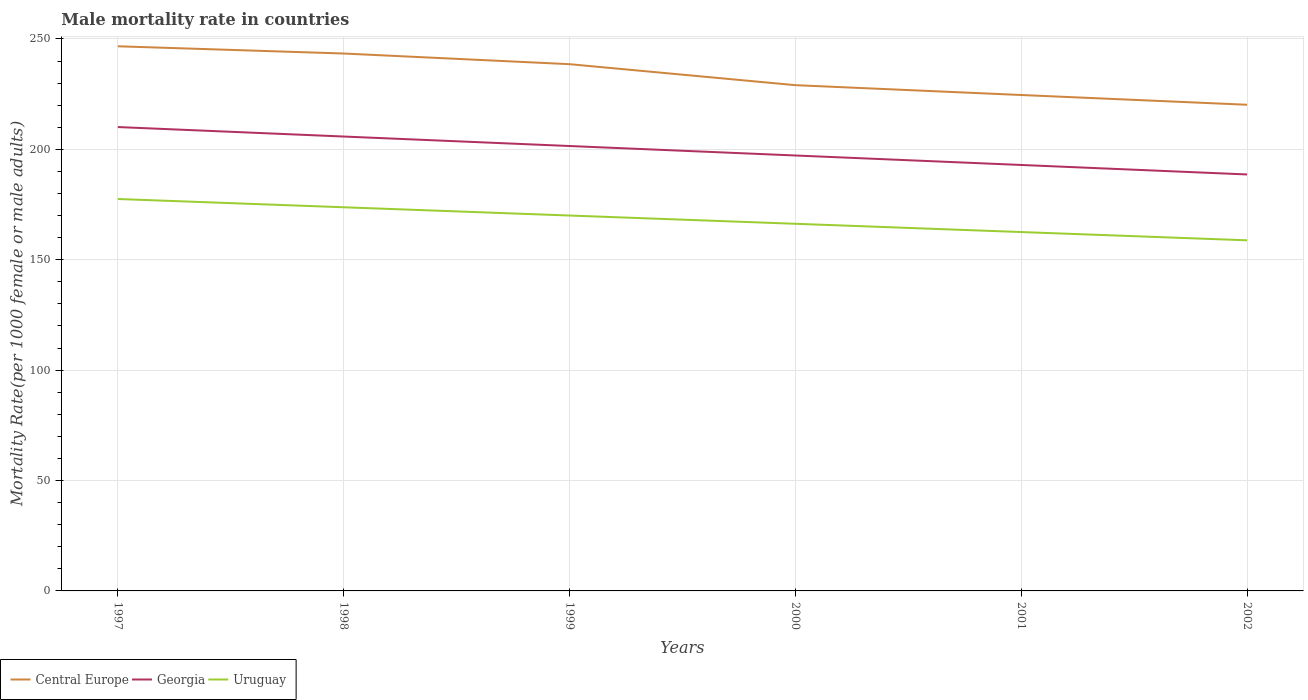Does the line corresponding to Uruguay intersect with the line corresponding to Georgia?
Make the answer very short. No. Is the number of lines equal to the number of legend labels?
Keep it short and to the point. Yes. Across all years, what is the maximum male mortality rate in Uruguay?
Make the answer very short. 158.8. In which year was the male mortality rate in Uruguay maximum?
Your answer should be compact. 2002. What is the total male mortality rate in Georgia in the graph?
Offer a very short reply. 17.18. What is the difference between the highest and the second highest male mortality rate in Central Europe?
Offer a terse response. 26.48. What is the difference between the highest and the lowest male mortality rate in Central Europe?
Your answer should be compact. 3. Is the male mortality rate in Uruguay strictly greater than the male mortality rate in Central Europe over the years?
Offer a very short reply. Yes. How many years are there in the graph?
Provide a succinct answer. 6. What is the difference between two consecutive major ticks on the Y-axis?
Your response must be concise. 50. What is the title of the graph?
Provide a succinct answer. Male mortality rate in countries. Does "Peru" appear as one of the legend labels in the graph?
Provide a succinct answer. No. What is the label or title of the Y-axis?
Offer a very short reply. Mortality Rate(per 1000 female or male adults). What is the Mortality Rate(per 1000 female or male adults) in Central Europe in 1997?
Give a very brief answer. 246.68. What is the Mortality Rate(per 1000 female or male adults) in Georgia in 1997?
Ensure brevity in your answer.  210.09. What is the Mortality Rate(per 1000 female or male adults) in Uruguay in 1997?
Offer a very short reply. 177.51. What is the Mortality Rate(per 1000 female or male adults) in Central Europe in 1998?
Your answer should be very brief. 243.4. What is the Mortality Rate(per 1000 female or male adults) in Georgia in 1998?
Give a very brief answer. 205.8. What is the Mortality Rate(per 1000 female or male adults) of Uruguay in 1998?
Ensure brevity in your answer.  173.76. What is the Mortality Rate(per 1000 female or male adults) of Central Europe in 1999?
Give a very brief answer. 238.57. What is the Mortality Rate(per 1000 female or male adults) of Georgia in 1999?
Provide a short and direct response. 201.51. What is the Mortality Rate(per 1000 female or male adults) in Uruguay in 1999?
Provide a succinct answer. 170.02. What is the Mortality Rate(per 1000 female or male adults) in Central Europe in 2000?
Your response must be concise. 229.07. What is the Mortality Rate(per 1000 female or male adults) of Georgia in 2000?
Keep it short and to the point. 197.21. What is the Mortality Rate(per 1000 female or male adults) in Uruguay in 2000?
Give a very brief answer. 166.28. What is the Mortality Rate(per 1000 female or male adults) in Central Europe in 2001?
Your answer should be very brief. 224.61. What is the Mortality Rate(per 1000 female or male adults) in Georgia in 2001?
Your answer should be compact. 192.92. What is the Mortality Rate(per 1000 female or male adults) in Uruguay in 2001?
Your answer should be compact. 162.54. What is the Mortality Rate(per 1000 female or male adults) of Central Europe in 2002?
Your response must be concise. 220.2. What is the Mortality Rate(per 1000 female or male adults) in Georgia in 2002?
Ensure brevity in your answer.  188.62. What is the Mortality Rate(per 1000 female or male adults) in Uruguay in 2002?
Ensure brevity in your answer.  158.8. Across all years, what is the maximum Mortality Rate(per 1000 female or male adults) in Central Europe?
Provide a short and direct response. 246.68. Across all years, what is the maximum Mortality Rate(per 1000 female or male adults) of Georgia?
Give a very brief answer. 210.09. Across all years, what is the maximum Mortality Rate(per 1000 female or male adults) in Uruguay?
Offer a terse response. 177.51. Across all years, what is the minimum Mortality Rate(per 1000 female or male adults) in Central Europe?
Provide a succinct answer. 220.2. Across all years, what is the minimum Mortality Rate(per 1000 female or male adults) of Georgia?
Offer a very short reply. 188.62. Across all years, what is the minimum Mortality Rate(per 1000 female or male adults) of Uruguay?
Offer a very short reply. 158.8. What is the total Mortality Rate(per 1000 female or male adults) in Central Europe in the graph?
Make the answer very short. 1402.52. What is the total Mortality Rate(per 1000 female or male adults) of Georgia in the graph?
Ensure brevity in your answer.  1196.16. What is the total Mortality Rate(per 1000 female or male adults) of Uruguay in the graph?
Make the answer very short. 1008.91. What is the difference between the Mortality Rate(per 1000 female or male adults) in Central Europe in 1997 and that in 1998?
Your answer should be compact. 3.28. What is the difference between the Mortality Rate(per 1000 female or male adults) of Georgia in 1997 and that in 1998?
Offer a very short reply. 4.29. What is the difference between the Mortality Rate(per 1000 female or male adults) of Uruguay in 1997 and that in 1998?
Your answer should be compact. 3.74. What is the difference between the Mortality Rate(per 1000 female or male adults) of Central Europe in 1997 and that in 1999?
Ensure brevity in your answer.  8.11. What is the difference between the Mortality Rate(per 1000 female or male adults) of Georgia in 1997 and that in 1999?
Offer a terse response. 8.59. What is the difference between the Mortality Rate(per 1000 female or male adults) in Uruguay in 1997 and that in 1999?
Offer a terse response. 7.48. What is the difference between the Mortality Rate(per 1000 female or male adults) in Central Europe in 1997 and that in 2000?
Make the answer very short. 17.61. What is the difference between the Mortality Rate(per 1000 female or male adults) of Georgia in 1997 and that in 2000?
Offer a terse response. 12.88. What is the difference between the Mortality Rate(per 1000 female or male adults) in Uruguay in 1997 and that in 2000?
Provide a short and direct response. 11.23. What is the difference between the Mortality Rate(per 1000 female or male adults) in Central Europe in 1997 and that in 2001?
Your answer should be compact. 22.07. What is the difference between the Mortality Rate(per 1000 female or male adults) in Georgia in 1997 and that in 2001?
Keep it short and to the point. 17.18. What is the difference between the Mortality Rate(per 1000 female or male adults) in Uruguay in 1997 and that in 2001?
Your answer should be very brief. 14.97. What is the difference between the Mortality Rate(per 1000 female or male adults) in Central Europe in 1997 and that in 2002?
Your answer should be very brief. 26.48. What is the difference between the Mortality Rate(per 1000 female or male adults) in Georgia in 1997 and that in 2002?
Your response must be concise. 21.47. What is the difference between the Mortality Rate(per 1000 female or male adults) of Uruguay in 1997 and that in 2002?
Your answer should be compact. 18.71. What is the difference between the Mortality Rate(per 1000 female or male adults) of Central Europe in 1998 and that in 1999?
Your answer should be compact. 4.83. What is the difference between the Mortality Rate(per 1000 female or male adults) in Georgia in 1998 and that in 1999?
Offer a very short reply. 4.29. What is the difference between the Mortality Rate(per 1000 female or male adults) of Uruguay in 1998 and that in 1999?
Your answer should be compact. 3.74. What is the difference between the Mortality Rate(per 1000 female or male adults) of Central Europe in 1998 and that in 2000?
Ensure brevity in your answer.  14.33. What is the difference between the Mortality Rate(per 1000 female or male adults) of Georgia in 1998 and that in 2000?
Ensure brevity in your answer.  8.59. What is the difference between the Mortality Rate(per 1000 female or male adults) in Uruguay in 1998 and that in 2000?
Ensure brevity in your answer.  7.48. What is the difference between the Mortality Rate(per 1000 female or male adults) in Central Europe in 1998 and that in 2001?
Make the answer very short. 18.79. What is the difference between the Mortality Rate(per 1000 female or male adults) of Georgia in 1998 and that in 2001?
Provide a succinct answer. 12.88. What is the difference between the Mortality Rate(per 1000 female or male adults) of Uruguay in 1998 and that in 2001?
Make the answer very short. 11.23. What is the difference between the Mortality Rate(per 1000 female or male adults) in Central Europe in 1998 and that in 2002?
Keep it short and to the point. 23.2. What is the difference between the Mortality Rate(per 1000 female or male adults) in Georgia in 1998 and that in 2002?
Offer a terse response. 17.18. What is the difference between the Mortality Rate(per 1000 female or male adults) in Uruguay in 1998 and that in 2002?
Offer a terse response. 14.97. What is the difference between the Mortality Rate(per 1000 female or male adults) of Central Europe in 1999 and that in 2000?
Give a very brief answer. 9.5. What is the difference between the Mortality Rate(per 1000 female or male adults) in Georgia in 1999 and that in 2000?
Keep it short and to the point. 4.29. What is the difference between the Mortality Rate(per 1000 female or male adults) of Uruguay in 1999 and that in 2000?
Ensure brevity in your answer.  3.74. What is the difference between the Mortality Rate(per 1000 female or male adults) of Central Europe in 1999 and that in 2001?
Ensure brevity in your answer.  13.96. What is the difference between the Mortality Rate(per 1000 female or male adults) of Georgia in 1999 and that in 2001?
Ensure brevity in your answer.  8.59. What is the difference between the Mortality Rate(per 1000 female or male adults) in Uruguay in 1999 and that in 2001?
Give a very brief answer. 7.48. What is the difference between the Mortality Rate(per 1000 female or male adults) of Central Europe in 1999 and that in 2002?
Your answer should be very brief. 18.37. What is the difference between the Mortality Rate(per 1000 female or male adults) in Georgia in 1999 and that in 2002?
Your answer should be very brief. 12.88. What is the difference between the Mortality Rate(per 1000 female or male adults) of Uruguay in 1999 and that in 2002?
Give a very brief answer. 11.23. What is the difference between the Mortality Rate(per 1000 female or male adults) in Central Europe in 2000 and that in 2001?
Your answer should be compact. 4.46. What is the difference between the Mortality Rate(per 1000 female or male adults) in Georgia in 2000 and that in 2001?
Your answer should be very brief. 4.29. What is the difference between the Mortality Rate(per 1000 female or male adults) in Uruguay in 2000 and that in 2001?
Keep it short and to the point. 3.74. What is the difference between the Mortality Rate(per 1000 female or male adults) of Central Europe in 2000 and that in 2002?
Offer a terse response. 8.87. What is the difference between the Mortality Rate(per 1000 female or male adults) of Georgia in 2000 and that in 2002?
Provide a short and direct response. 8.59. What is the difference between the Mortality Rate(per 1000 female or male adults) in Uruguay in 2000 and that in 2002?
Offer a terse response. 7.48. What is the difference between the Mortality Rate(per 1000 female or male adults) in Central Europe in 2001 and that in 2002?
Offer a terse response. 4.41. What is the difference between the Mortality Rate(per 1000 female or male adults) of Georgia in 2001 and that in 2002?
Make the answer very short. 4.29. What is the difference between the Mortality Rate(per 1000 female or male adults) in Uruguay in 2001 and that in 2002?
Keep it short and to the point. 3.74. What is the difference between the Mortality Rate(per 1000 female or male adults) of Central Europe in 1997 and the Mortality Rate(per 1000 female or male adults) of Georgia in 1998?
Your response must be concise. 40.88. What is the difference between the Mortality Rate(per 1000 female or male adults) of Central Europe in 1997 and the Mortality Rate(per 1000 female or male adults) of Uruguay in 1998?
Your response must be concise. 72.91. What is the difference between the Mortality Rate(per 1000 female or male adults) of Georgia in 1997 and the Mortality Rate(per 1000 female or male adults) of Uruguay in 1998?
Offer a very short reply. 36.33. What is the difference between the Mortality Rate(per 1000 female or male adults) of Central Europe in 1997 and the Mortality Rate(per 1000 female or male adults) of Georgia in 1999?
Give a very brief answer. 45.17. What is the difference between the Mortality Rate(per 1000 female or male adults) in Central Europe in 1997 and the Mortality Rate(per 1000 female or male adults) in Uruguay in 1999?
Ensure brevity in your answer.  76.66. What is the difference between the Mortality Rate(per 1000 female or male adults) of Georgia in 1997 and the Mortality Rate(per 1000 female or male adults) of Uruguay in 1999?
Provide a succinct answer. 40.07. What is the difference between the Mortality Rate(per 1000 female or male adults) in Central Europe in 1997 and the Mortality Rate(per 1000 female or male adults) in Georgia in 2000?
Make the answer very short. 49.47. What is the difference between the Mortality Rate(per 1000 female or male adults) in Central Europe in 1997 and the Mortality Rate(per 1000 female or male adults) in Uruguay in 2000?
Your response must be concise. 80.4. What is the difference between the Mortality Rate(per 1000 female or male adults) of Georgia in 1997 and the Mortality Rate(per 1000 female or male adults) of Uruguay in 2000?
Your response must be concise. 43.81. What is the difference between the Mortality Rate(per 1000 female or male adults) in Central Europe in 1997 and the Mortality Rate(per 1000 female or male adults) in Georgia in 2001?
Give a very brief answer. 53.76. What is the difference between the Mortality Rate(per 1000 female or male adults) in Central Europe in 1997 and the Mortality Rate(per 1000 female or male adults) in Uruguay in 2001?
Ensure brevity in your answer.  84.14. What is the difference between the Mortality Rate(per 1000 female or male adults) in Georgia in 1997 and the Mortality Rate(per 1000 female or male adults) in Uruguay in 2001?
Your response must be concise. 47.55. What is the difference between the Mortality Rate(per 1000 female or male adults) of Central Europe in 1997 and the Mortality Rate(per 1000 female or male adults) of Georgia in 2002?
Your answer should be compact. 58.05. What is the difference between the Mortality Rate(per 1000 female or male adults) in Central Europe in 1997 and the Mortality Rate(per 1000 female or male adults) in Uruguay in 2002?
Provide a short and direct response. 87.88. What is the difference between the Mortality Rate(per 1000 female or male adults) in Georgia in 1997 and the Mortality Rate(per 1000 female or male adults) in Uruguay in 2002?
Your answer should be compact. 51.3. What is the difference between the Mortality Rate(per 1000 female or male adults) in Central Europe in 1998 and the Mortality Rate(per 1000 female or male adults) in Georgia in 1999?
Provide a succinct answer. 41.89. What is the difference between the Mortality Rate(per 1000 female or male adults) of Central Europe in 1998 and the Mortality Rate(per 1000 female or male adults) of Uruguay in 1999?
Offer a very short reply. 73.38. What is the difference between the Mortality Rate(per 1000 female or male adults) in Georgia in 1998 and the Mortality Rate(per 1000 female or male adults) in Uruguay in 1999?
Offer a terse response. 35.78. What is the difference between the Mortality Rate(per 1000 female or male adults) in Central Europe in 1998 and the Mortality Rate(per 1000 female or male adults) in Georgia in 2000?
Make the answer very short. 46.19. What is the difference between the Mortality Rate(per 1000 female or male adults) in Central Europe in 1998 and the Mortality Rate(per 1000 female or male adults) in Uruguay in 2000?
Your answer should be very brief. 77.12. What is the difference between the Mortality Rate(per 1000 female or male adults) in Georgia in 1998 and the Mortality Rate(per 1000 female or male adults) in Uruguay in 2000?
Provide a succinct answer. 39.52. What is the difference between the Mortality Rate(per 1000 female or male adults) in Central Europe in 1998 and the Mortality Rate(per 1000 female or male adults) in Georgia in 2001?
Give a very brief answer. 50.48. What is the difference between the Mortality Rate(per 1000 female or male adults) of Central Europe in 1998 and the Mortality Rate(per 1000 female or male adults) of Uruguay in 2001?
Your answer should be very brief. 80.86. What is the difference between the Mortality Rate(per 1000 female or male adults) of Georgia in 1998 and the Mortality Rate(per 1000 female or male adults) of Uruguay in 2001?
Your answer should be very brief. 43.26. What is the difference between the Mortality Rate(per 1000 female or male adults) of Central Europe in 1998 and the Mortality Rate(per 1000 female or male adults) of Georgia in 2002?
Your answer should be compact. 54.77. What is the difference between the Mortality Rate(per 1000 female or male adults) of Central Europe in 1998 and the Mortality Rate(per 1000 female or male adults) of Uruguay in 2002?
Give a very brief answer. 84.6. What is the difference between the Mortality Rate(per 1000 female or male adults) of Georgia in 1998 and the Mortality Rate(per 1000 female or male adults) of Uruguay in 2002?
Offer a terse response. 47. What is the difference between the Mortality Rate(per 1000 female or male adults) in Central Europe in 1999 and the Mortality Rate(per 1000 female or male adults) in Georgia in 2000?
Keep it short and to the point. 41.36. What is the difference between the Mortality Rate(per 1000 female or male adults) of Central Europe in 1999 and the Mortality Rate(per 1000 female or male adults) of Uruguay in 2000?
Make the answer very short. 72.29. What is the difference between the Mortality Rate(per 1000 female or male adults) of Georgia in 1999 and the Mortality Rate(per 1000 female or male adults) of Uruguay in 2000?
Provide a short and direct response. 35.23. What is the difference between the Mortality Rate(per 1000 female or male adults) in Central Europe in 1999 and the Mortality Rate(per 1000 female or male adults) in Georgia in 2001?
Make the answer very short. 45.65. What is the difference between the Mortality Rate(per 1000 female or male adults) in Central Europe in 1999 and the Mortality Rate(per 1000 female or male adults) in Uruguay in 2001?
Give a very brief answer. 76.03. What is the difference between the Mortality Rate(per 1000 female or male adults) of Georgia in 1999 and the Mortality Rate(per 1000 female or male adults) of Uruguay in 2001?
Provide a short and direct response. 38.97. What is the difference between the Mortality Rate(per 1000 female or male adults) in Central Europe in 1999 and the Mortality Rate(per 1000 female or male adults) in Georgia in 2002?
Your answer should be very brief. 49.94. What is the difference between the Mortality Rate(per 1000 female or male adults) of Central Europe in 1999 and the Mortality Rate(per 1000 female or male adults) of Uruguay in 2002?
Offer a terse response. 79.77. What is the difference between the Mortality Rate(per 1000 female or male adults) in Georgia in 1999 and the Mortality Rate(per 1000 female or male adults) in Uruguay in 2002?
Make the answer very short. 42.71. What is the difference between the Mortality Rate(per 1000 female or male adults) of Central Europe in 2000 and the Mortality Rate(per 1000 female or male adults) of Georgia in 2001?
Your answer should be compact. 36.15. What is the difference between the Mortality Rate(per 1000 female or male adults) of Central Europe in 2000 and the Mortality Rate(per 1000 female or male adults) of Uruguay in 2001?
Ensure brevity in your answer.  66.53. What is the difference between the Mortality Rate(per 1000 female or male adults) in Georgia in 2000 and the Mortality Rate(per 1000 female or male adults) in Uruguay in 2001?
Provide a short and direct response. 34.67. What is the difference between the Mortality Rate(per 1000 female or male adults) in Central Europe in 2000 and the Mortality Rate(per 1000 female or male adults) in Georgia in 2002?
Give a very brief answer. 40.44. What is the difference between the Mortality Rate(per 1000 female or male adults) of Central Europe in 2000 and the Mortality Rate(per 1000 female or male adults) of Uruguay in 2002?
Your answer should be very brief. 70.27. What is the difference between the Mortality Rate(per 1000 female or male adults) of Georgia in 2000 and the Mortality Rate(per 1000 female or male adults) of Uruguay in 2002?
Offer a terse response. 38.42. What is the difference between the Mortality Rate(per 1000 female or male adults) of Central Europe in 2001 and the Mortality Rate(per 1000 female or male adults) of Georgia in 2002?
Your answer should be very brief. 35.98. What is the difference between the Mortality Rate(per 1000 female or male adults) of Central Europe in 2001 and the Mortality Rate(per 1000 female or male adults) of Uruguay in 2002?
Provide a short and direct response. 65.81. What is the difference between the Mortality Rate(per 1000 female or male adults) of Georgia in 2001 and the Mortality Rate(per 1000 female or male adults) of Uruguay in 2002?
Your response must be concise. 34.12. What is the average Mortality Rate(per 1000 female or male adults) in Central Europe per year?
Offer a terse response. 233.75. What is the average Mortality Rate(per 1000 female or male adults) in Georgia per year?
Provide a short and direct response. 199.36. What is the average Mortality Rate(per 1000 female or male adults) in Uruguay per year?
Your answer should be very brief. 168.15. In the year 1997, what is the difference between the Mortality Rate(per 1000 female or male adults) of Central Europe and Mortality Rate(per 1000 female or male adults) of Georgia?
Your answer should be very brief. 36.58. In the year 1997, what is the difference between the Mortality Rate(per 1000 female or male adults) in Central Europe and Mortality Rate(per 1000 female or male adults) in Uruguay?
Give a very brief answer. 69.17. In the year 1997, what is the difference between the Mortality Rate(per 1000 female or male adults) of Georgia and Mortality Rate(per 1000 female or male adults) of Uruguay?
Offer a very short reply. 32.59. In the year 1998, what is the difference between the Mortality Rate(per 1000 female or male adults) of Central Europe and Mortality Rate(per 1000 female or male adults) of Georgia?
Offer a very short reply. 37.6. In the year 1998, what is the difference between the Mortality Rate(per 1000 female or male adults) of Central Europe and Mortality Rate(per 1000 female or male adults) of Uruguay?
Keep it short and to the point. 69.63. In the year 1998, what is the difference between the Mortality Rate(per 1000 female or male adults) in Georgia and Mortality Rate(per 1000 female or male adults) in Uruguay?
Ensure brevity in your answer.  32.04. In the year 1999, what is the difference between the Mortality Rate(per 1000 female or male adults) of Central Europe and Mortality Rate(per 1000 female or male adults) of Georgia?
Your answer should be very brief. 37.06. In the year 1999, what is the difference between the Mortality Rate(per 1000 female or male adults) in Central Europe and Mortality Rate(per 1000 female or male adults) in Uruguay?
Provide a succinct answer. 68.55. In the year 1999, what is the difference between the Mortality Rate(per 1000 female or male adults) in Georgia and Mortality Rate(per 1000 female or male adults) in Uruguay?
Provide a succinct answer. 31.48. In the year 2000, what is the difference between the Mortality Rate(per 1000 female or male adults) of Central Europe and Mortality Rate(per 1000 female or male adults) of Georgia?
Your answer should be compact. 31.85. In the year 2000, what is the difference between the Mortality Rate(per 1000 female or male adults) of Central Europe and Mortality Rate(per 1000 female or male adults) of Uruguay?
Make the answer very short. 62.78. In the year 2000, what is the difference between the Mortality Rate(per 1000 female or male adults) in Georgia and Mortality Rate(per 1000 female or male adults) in Uruguay?
Provide a succinct answer. 30.93. In the year 2001, what is the difference between the Mortality Rate(per 1000 female or male adults) in Central Europe and Mortality Rate(per 1000 female or male adults) in Georgia?
Keep it short and to the point. 31.69. In the year 2001, what is the difference between the Mortality Rate(per 1000 female or male adults) of Central Europe and Mortality Rate(per 1000 female or male adults) of Uruguay?
Keep it short and to the point. 62.07. In the year 2001, what is the difference between the Mortality Rate(per 1000 female or male adults) of Georgia and Mortality Rate(per 1000 female or male adults) of Uruguay?
Keep it short and to the point. 30.38. In the year 2002, what is the difference between the Mortality Rate(per 1000 female or male adults) in Central Europe and Mortality Rate(per 1000 female or male adults) in Georgia?
Make the answer very short. 31.57. In the year 2002, what is the difference between the Mortality Rate(per 1000 female or male adults) of Central Europe and Mortality Rate(per 1000 female or male adults) of Uruguay?
Offer a terse response. 61.4. In the year 2002, what is the difference between the Mortality Rate(per 1000 female or male adults) of Georgia and Mortality Rate(per 1000 female or male adults) of Uruguay?
Keep it short and to the point. 29.83. What is the ratio of the Mortality Rate(per 1000 female or male adults) of Central Europe in 1997 to that in 1998?
Ensure brevity in your answer.  1.01. What is the ratio of the Mortality Rate(per 1000 female or male adults) of Georgia in 1997 to that in 1998?
Offer a very short reply. 1.02. What is the ratio of the Mortality Rate(per 1000 female or male adults) in Uruguay in 1997 to that in 1998?
Provide a succinct answer. 1.02. What is the ratio of the Mortality Rate(per 1000 female or male adults) of Central Europe in 1997 to that in 1999?
Provide a succinct answer. 1.03. What is the ratio of the Mortality Rate(per 1000 female or male adults) of Georgia in 1997 to that in 1999?
Offer a very short reply. 1.04. What is the ratio of the Mortality Rate(per 1000 female or male adults) in Uruguay in 1997 to that in 1999?
Offer a very short reply. 1.04. What is the ratio of the Mortality Rate(per 1000 female or male adults) of Georgia in 1997 to that in 2000?
Ensure brevity in your answer.  1.07. What is the ratio of the Mortality Rate(per 1000 female or male adults) of Uruguay in 1997 to that in 2000?
Your answer should be compact. 1.07. What is the ratio of the Mortality Rate(per 1000 female or male adults) of Central Europe in 1997 to that in 2001?
Your answer should be compact. 1.1. What is the ratio of the Mortality Rate(per 1000 female or male adults) in Georgia in 1997 to that in 2001?
Offer a terse response. 1.09. What is the ratio of the Mortality Rate(per 1000 female or male adults) in Uruguay in 1997 to that in 2001?
Your answer should be very brief. 1.09. What is the ratio of the Mortality Rate(per 1000 female or male adults) of Central Europe in 1997 to that in 2002?
Your response must be concise. 1.12. What is the ratio of the Mortality Rate(per 1000 female or male adults) of Georgia in 1997 to that in 2002?
Give a very brief answer. 1.11. What is the ratio of the Mortality Rate(per 1000 female or male adults) of Uruguay in 1997 to that in 2002?
Ensure brevity in your answer.  1.12. What is the ratio of the Mortality Rate(per 1000 female or male adults) of Central Europe in 1998 to that in 1999?
Your answer should be very brief. 1.02. What is the ratio of the Mortality Rate(per 1000 female or male adults) in Georgia in 1998 to that in 1999?
Ensure brevity in your answer.  1.02. What is the ratio of the Mortality Rate(per 1000 female or male adults) in Central Europe in 1998 to that in 2000?
Give a very brief answer. 1.06. What is the ratio of the Mortality Rate(per 1000 female or male adults) of Georgia in 1998 to that in 2000?
Keep it short and to the point. 1.04. What is the ratio of the Mortality Rate(per 1000 female or male adults) of Uruguay in 1998 to that in 2000?
Provide a short and direct response. 1.04. What is the ratio of the Mortality Rate(per 1000 female or male adults) in Central Europe in 1998 to that in 2001?
Give a very brief answer. 1.08. What is the ratio of the Mortality Rate(per 1000 female or male adults) in Georgia in 1998 to that in 2001?
Offer a very short reply. 1.07. What is the ratio of the Mortality Rate(per 1000 female or male adults) in Uruguay in 1998 to that in 2001?
Offer a very short reply. 1.07. What is the ratio of the Mortality Rate(per 1000 female or male adults) of Central Europe in 1998 to that in 2002?
Provide a short and direct response. 1.11. What is the ratio of the Mortality Rate(per 1000 female or male adults) in Georgia in 1998 to that in 2002?
Make the answer very short. 1.09. What is the ratio of the Mortality Rate(per 1000 female or male adults) of Uruguay in 1998 to that in 2002?
Provide a succinct answer. 1.09. What is the ratio of the Mortality Rate(per 1000 female or male adults) in Central Europe in 1999 to that in 2000?
Provide a succinct answer. 1.04. What is the ratio of the Mortality Rate(per 1000 female or male adults) in Georgia in 1999 to that in 2000?
Your answer should be very brief. 1.02. What is the ratio of the Mortality Rate(per 1000 female or male adults) in Uruguay in 1999 to that in 2000?
Make the answer very short. 1.02. What is the ratio of the Mortality Rate(per 1000 female or male adults) of Central Europe in 1999 to that in 2001?
Make the answer very short. 1.06. What is the ratio of the Mortality Rate(per 1000 female or male adults) in Georgia in 1999 to that in 2001?
Your answer should be very brief. 1.04. What is the ratio of the Mortality Rate(per 1000 female or male adults) of Uruguay in 1999 to that in 2001?
Your answer should be compact. 1.05. What is the ratio of the Mortality Rate(per 1000 female or male adults) of Central Europe in 1999 to that in 2002?
Keep it short and to the point. 1.08. What is the ratio of the Mortality Rate(per 1000 female or male adults) in Georgia in 1999 to that in 2002?
Ensure brevity in your answer.  1.07. What is the ratio of the Mortality Rate(per 1000 female or male adults) of Uruguay in 1999 to that in 2002?
Your answer should be compact. 1.07. What is the ratio of the Mortality Rate(per 1000 female or male adults) of Central Europe in 2000 to that in 2001?
Ensure brevity in your answer.  1.02. What is the ratio of the Mortality Rate(per 1000 female or male adults) in Georgia in 2000 to that in 2001?
Provide a short and direct response. 1.02. What is the ratio of the Mortality Rate(per 1000 female or male adults) in Uruguay in 2000 to that in 2001?
Give a very brief answer. 1.02. What is the ratio of the Mortality Rate(per 1000 female or male adults) in Central Europe in 2000 to that in 2002?
Offer a very short reply. 1.04. What is the ratio of the Mortality Rate(per 1000 female or male adults) in Georgia in 2000 to that in 2002?
Your answer should be compact. 1.05. What is the ratio of the Mortality Rate(per 1000 female or male adults) in Uruguay in 2000 to that in 2002?
Keep it short and to the point. 1.05. What is the ratio of the Mortality Rate(per 1000 female or male adults) of Georgia in 2001 to that in 2002?
Give a very brief answer. 1.02. What is the ratio of the Mortality Rate(per 1000 female or male adults) in Uruguay in 2001 to that in 2002?
Your answer should be very brief. 1.02. What is the difference between the highest and the second highest Mortality Rate(per 1000 female or male adults) of Central Europe?
Make the answer very short. 3.28. What is the difference between the highest and the second highest Mortality Rate(per 1000 female or male adults) in Georgia?
Keep it short and to the point. 4.29. What is the difference between the highest and the second highest Mortality Rate(per 1000 female or male adults) in Uruguay?
Your answer should be compact. 3.74. What is the difference between the highest and the lowest Mortality Rate(per 1000 female or male adults) of Central Europe?
Make the answer very short. 26.48. What is the difference between the highest and the lowest Mortality Rate(per 1000 female or male adults) of Georgia?
Ensure brevity in your answer.  21.47. What is the difference between the highest and the lowest Mortality Rate(per 1000 female or male adults) in Uruguay?
Your response must be concise. 18.71. 